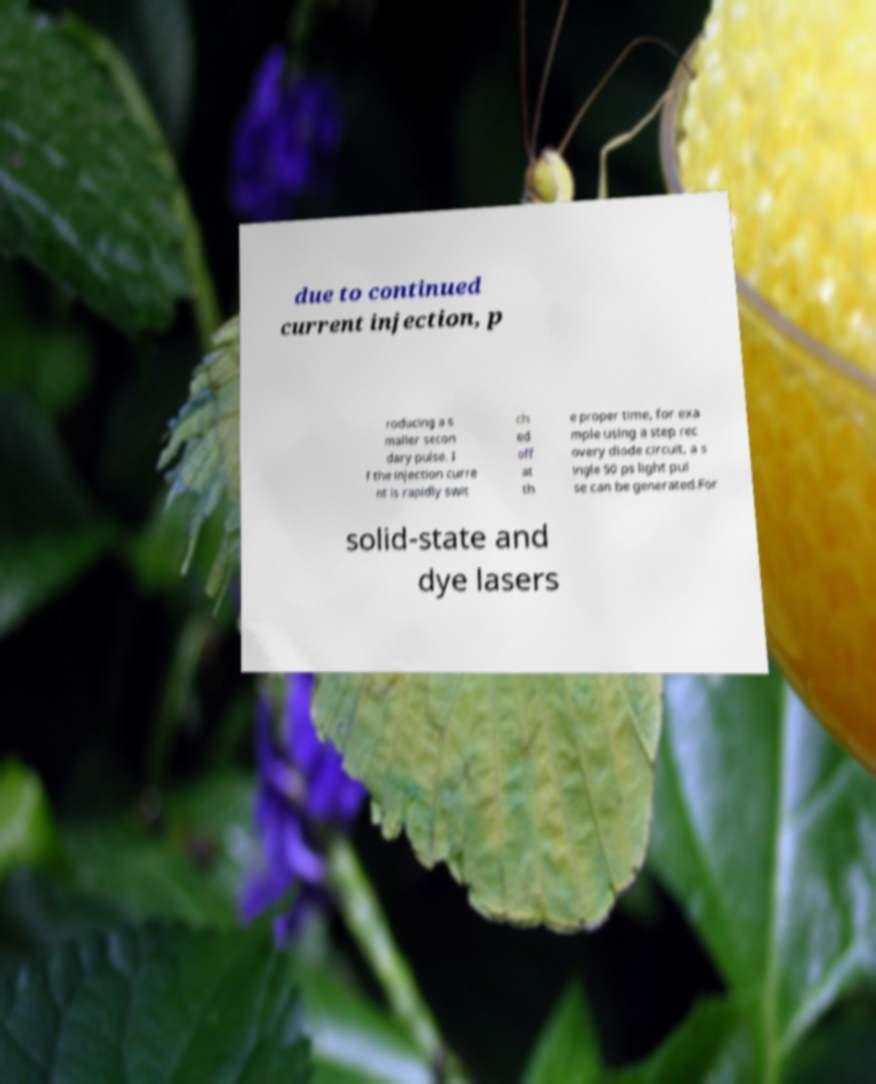What messages or text are displayed in this image? I need them in a readable, typed format. due to continued current injection, p roducing a s maller secon dary pulse. I f the injection curre nt is rapidly swit ch ed off at th e proper time, for exa mple using a step rec overy diode circuit, a s ingle 50 ps light pul se can be generated.For solid-state and dye lasers 